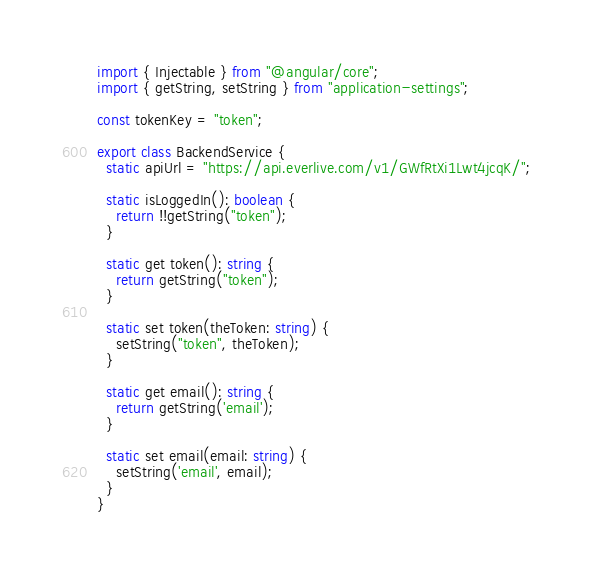Convert code to text. <code><loc_0><loc_0><loc_500><loc_500><_TypeScript_>import { Injectable } from "@angular/core";
import { getString, setString } from "application-settings";

const tokenKey = "token";

export class BackendService {
  static apiUrl = "https://api.everlive.com/v1/GWfRtXi1Lwt4jcqK/";

  static isLoggedIn(): boolean {
    return !!getString("token");
  }

  static get token(): string {
    return getString("token");
  }

  static set token(theToken: string) {
    setString("token", theToken);
  }

  static get email(): string {
    return getString('email');
  }

  static set email(email: string) {
    setString('email', email);
  }
}
</code> 